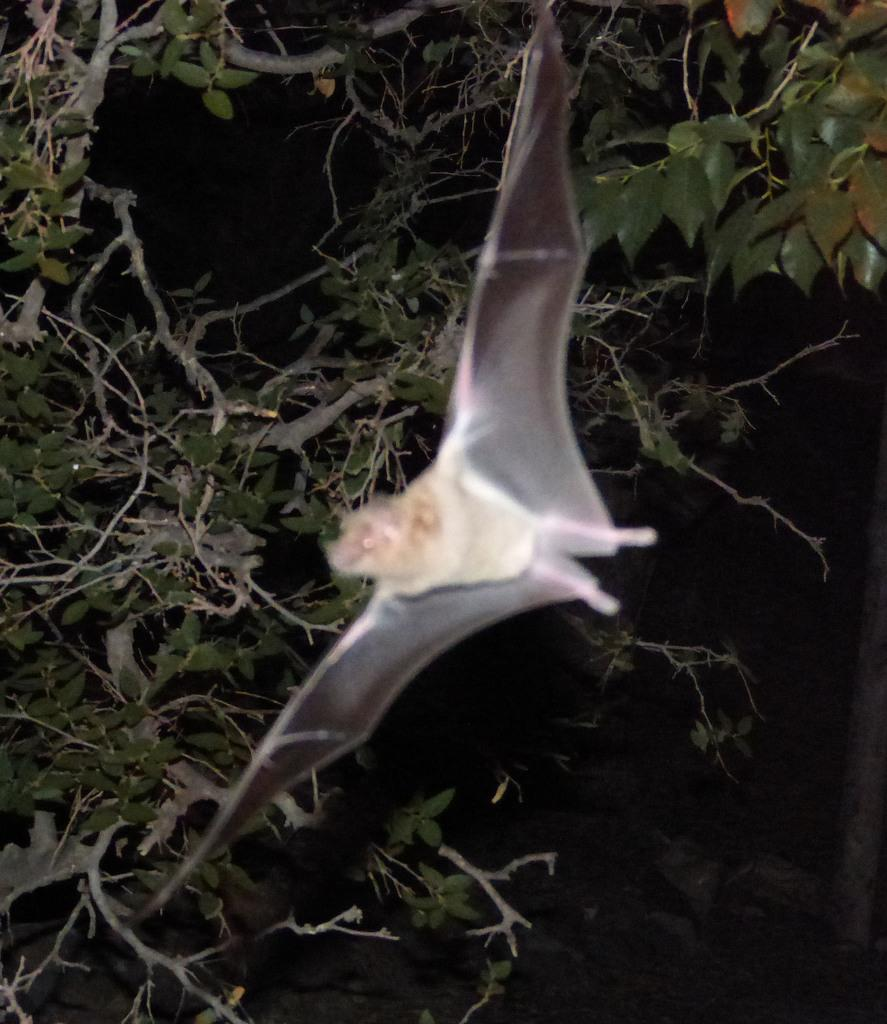What is the main subject of the image? The main subject of the image is a bird flying. What can be seen in the background of the image? There are trees in the background of the image. How would you describe the lighting in the image? The background of the image is dark. What type of appliance is the stranger using in the image? There is no stranger or appliance present in the image; it features a bird flying in front of trees with a dark background. 